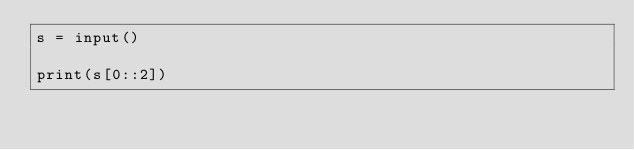Convert code to text. <code><loc_0><loc_0><loc_500><loc_500><_Python_>s = input()

print(s[0::2])</code> 